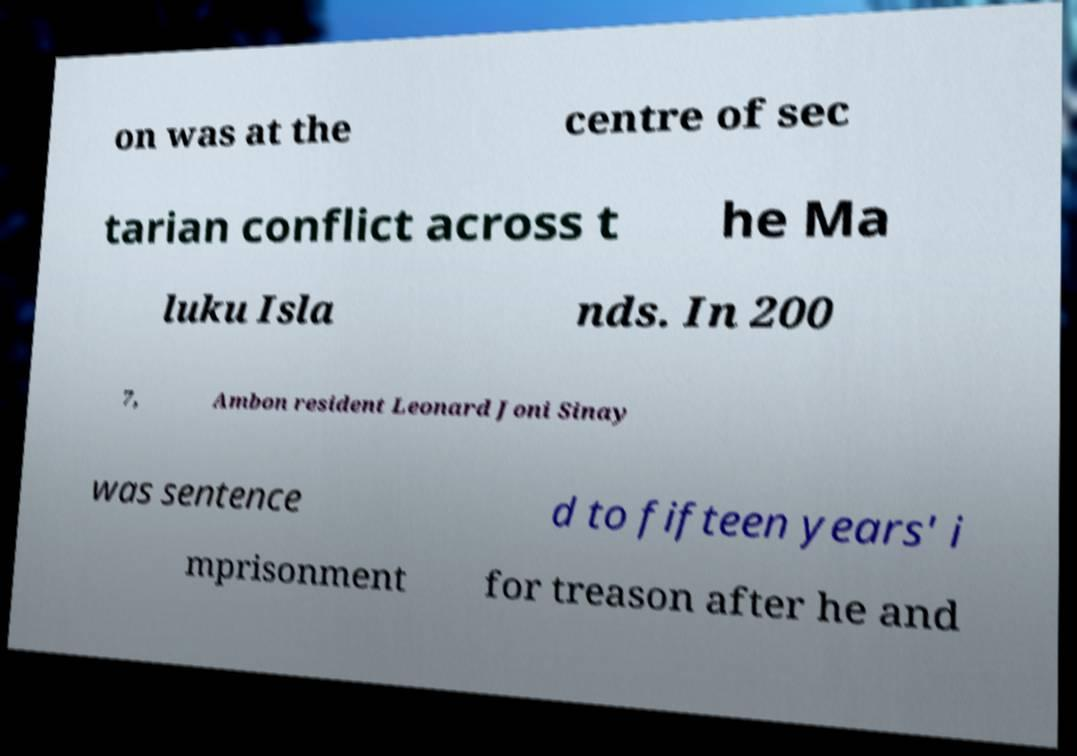Can you read and provide the text displayed in the image?This photo seems to have some interesting text. Can you extract and type it out for me? on was at the centre of sec tarian conflict across t he Ma luku Isla nds. In 200 7, Ambon resident Leonard Joni Sinay was sentence d to fifteen years' i mprisonment for treason after he and 